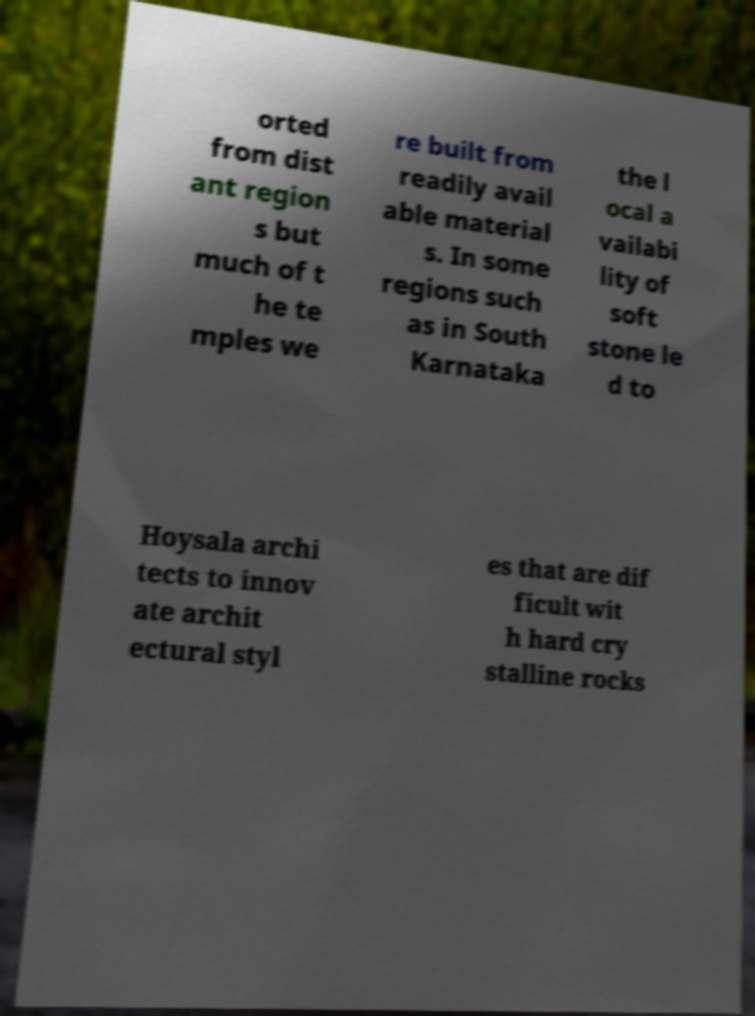Could you extract and type out the text from this image? orted from dist ant region s but much of t he te mples we re built from readily avail able material s. In some regions such as in South Karnataka the l ocal a vailabi lity of soft stone le d to Hoysala archi tects to innov ate archit ectural styl es that are dif ficult wit h hard cry stalline rocks 